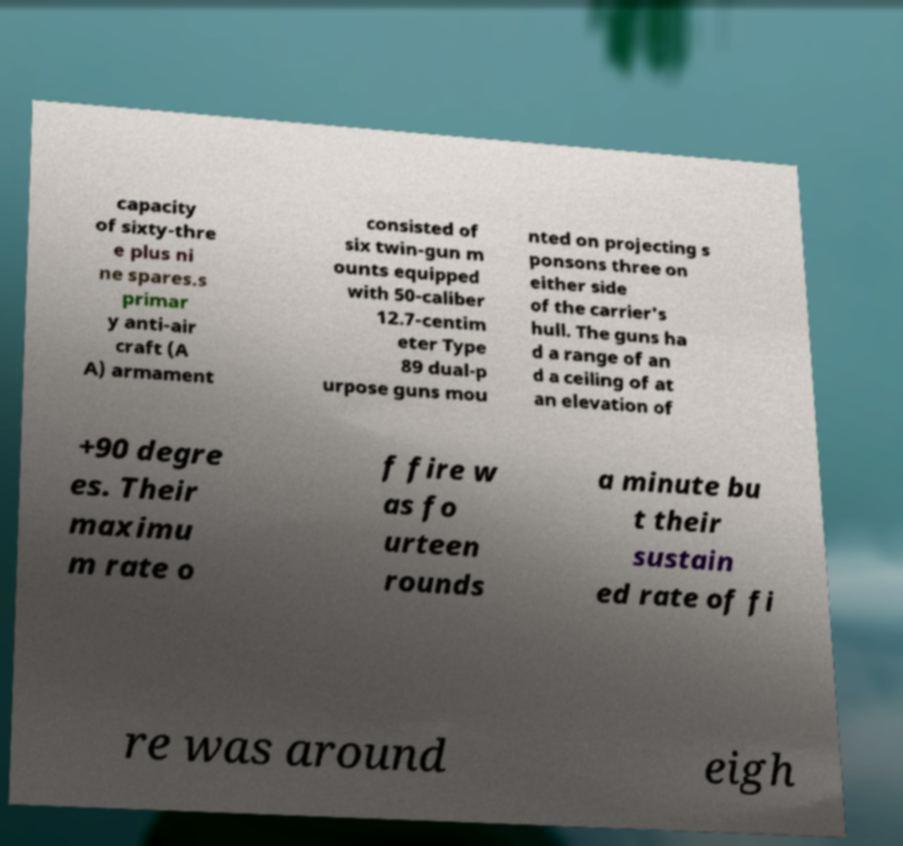There's text embedded in this image that I need extracted. Can you transcribe it verbatim? capacity of sixty-thre e plus ni ne spares.s primar y anti-air craft (A A) armament consisted of six twin-gun m ounts equipped with 50-caliber 12.7-centim eter Type 89 dual-p urpose guns mou nted on projecting s ponsons three on either side of the carrier's hull. The guns ha d a range of an d a ceiling of at an elevation of +90 degre es. Their maximu m rate o f fire w as fo urteen rounds a minute bu t their sustain ed rate of fi re was around eigh 